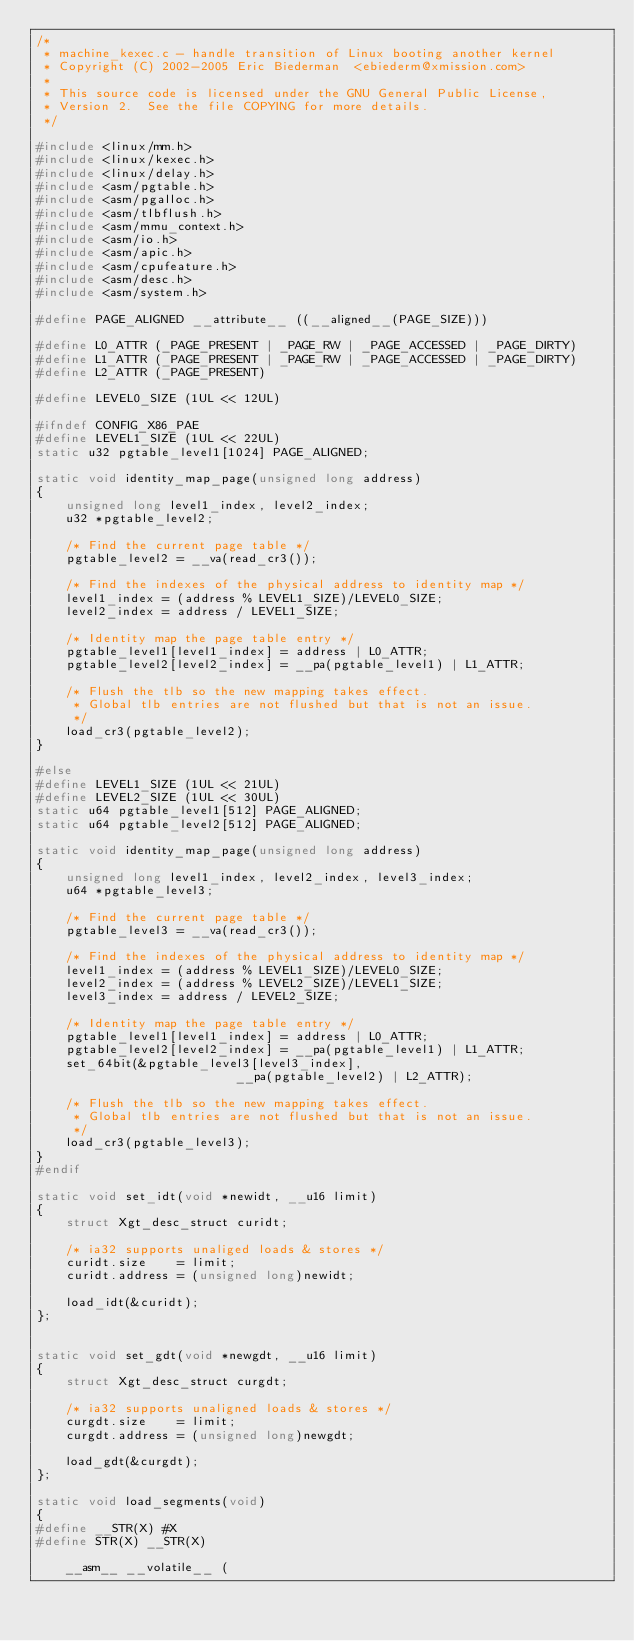<code> <loc_0><loc_0><loc_500><loc_500><_C_>/*
 * machine_kexec.c - handle transition of Linux booting another kernel
 * Copyright (C) 2002-2005 Eric Biederman  <ebiederm@xmission.com>
 *
 * This source code is licensed under the GNU General Public License,
 * Version 2.  See the file COPYING for more details.
 */

#include <linux/mm.h>
#include <linux/kexec.h>
#include <linux/delay.h>
#include <asm/pgtable.h>
#include <asm/pgalloc.h>
#include <asm/tlbflush.h>
#include <asm/mmu_context.h>
#include <asm/io.h>
#include <asm/apic.h>
#include <asm/cpufeature.h>
#include <asm/desc.h>
#include <asm/system.h>

#define PAGE_ALIGNED __attribute__ ((__aligned__(PAGE_SIZE)))

#define L0_ATTR (_PAGE_PRESENT | _PAGE_RW | _PAGE_ACCESSED | _PAGE_DIRTY)
#define L1_ATTR (_PAGE_PRESENT | _PAGE_RW | _PAGE_ACCESSED | _PAGE_DIRTY)
#define L2_ATTR (_PAGE_PRESENT)

#define LEVEL0_SIZE (1UL << 12UL)

#ifndef CONFIG_X86_PAE
#define LEVEL1_SIZE (1UL << 22UL)
static u32 pgtable_level1[1024] PAGE_ALIGNED;

static void identity_map_page(unsigned long address)
{
	unsigned long level1_index, level2_index;
	u32 *pgtable_level2;

	/* Find the current page table */
	pgtable_level2 = __va(read_cr3());

	/* Find the indexes of the physical address to identity map */
	level1_index = (address % LEVEL1_SIZE)/LEVEL0_SIZE;
	level2_index = address / LEVEL1_SIZE;

	/* Identity map the page table entry */
	pgtable_level1[level1_index] = address | L0_ATTR;
	pgtable_level2[level2_index] = __pa(pgtable_level1) | L1_ATTR;

	/* Flush the tlb so the new mapping takes effect.
	 * Global tlb entries are not flushed but that is not an issue.
	 */
	load_cr3(pgtable_level2);
}

#else
#define LEVEL1_SIZE (1UL << 21UL)
#define LEVEL2_SIZE (1UL << 30UL)
static u64 pgtable_level1[512] PAGE_ALIGNED;
static u64 pgtable_level2[512] PAGE_ALIGNED;

static void identity_map_page(unsigned long address)
{
	unsigned long level1_index, level2_index, level3_index;
	u64 *pgtable_level3;

	/* Find the current page table */
	pgtable_level3 = __va(read_cr3());

	/* Find the indexes of the physical address to identity map */
	level1_index = (address % LEVEL1_SIZE)/LEVEL0_SIZE;
	level2_index = (address % LEVEL2_SIZE)/LEVEL1_SIZE;
	level3_index = address / LEVEL2_SIZE;

	/* Identity map the page table entry */
	pgtable_level1[level1_index] = address | L0_ATTR;
	pgtable_level2[level2_index] = __pa(pgtable_level1) | L1_ATTR;
	set_64bit(&pgtable_level3[level3_index],
					       __pa(pgtable_level2) | L2_ATTR);

	/* Flush the tlb so the new mapping takes effect.
	 * Global tlb entries are not flushed but that is not an issue.
	 */
	load_cr3(pgtable_level3);
}
#endif

static void set_idt(void *newidt, __u16 limit)
{
	struct Xgt_desc_struct curidt;

	/* ia32 supports unaliged loads & stores */
	curidt.size    = limit;
	curidt.address = (unsigned long)newidt;

	load_idt(&curidt);
};


static void set_gdt(void *newgdt, __u16 limit)
{
	struct Xgt_desc_struct curgdt;

	/* ia32 supports unaligned loads & stores */
	curgdt.size    = limit;
	curgdt.address = (unsigned long)newgdt;

	load_gdt(&curgdt);
};

static void load_segments(void)
{
#define __STR(X) #X
#define STR(X) __STR(X)

	__asm__ __volatile__ (</code> 